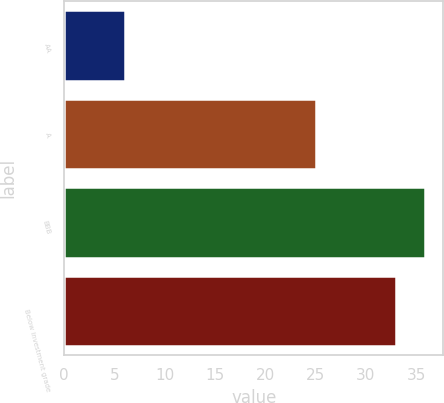Convert chart. <chart><loc_0><loc_0><loc_500><loc_500><bar_chart><fcel>AA<fcel>A<fcel>BBB<fcel>Below investment grade<nl><fcel>6<fcel>25<fcel>35.9<fcel>33<nl></chart> 